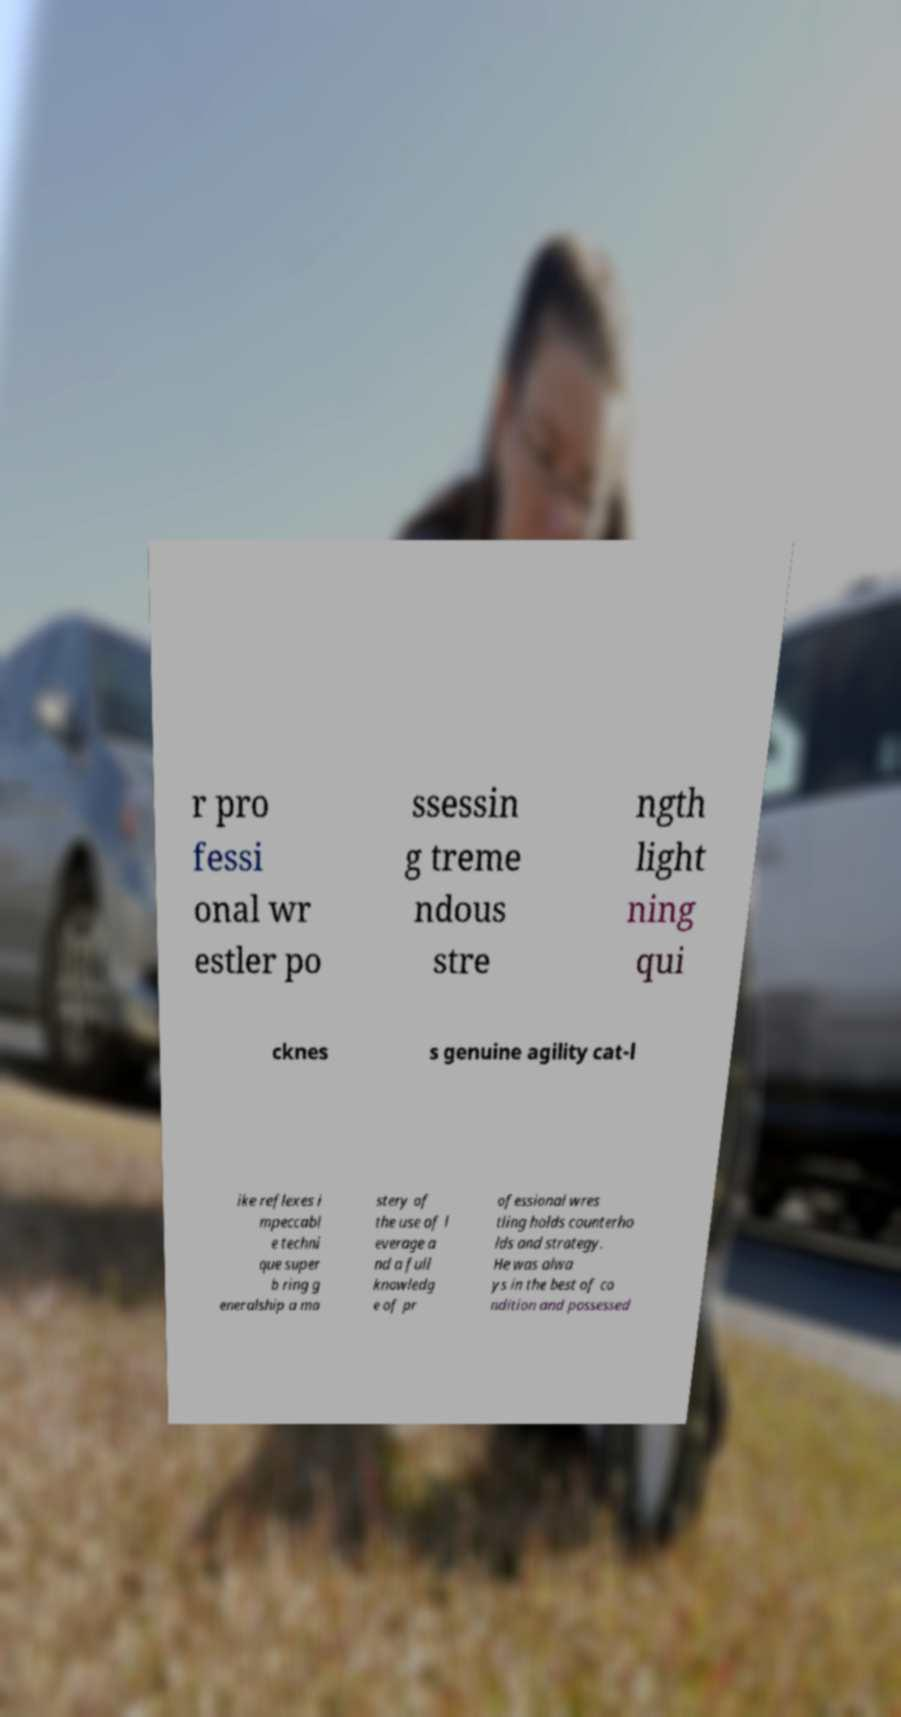Can you read and provide the text displayed in the image?This photo seems to have some interesting text. Can you extract and type it out for me? r pro fessi onal wr estler po ssessin g treme ndous stre ngth light ning qui cknes s genuine agility cat-l ike reflexes i mpeccabl e techni que super b ring g eneralship a ma stery of the use of l everage a nd a full knowledg e of pr ofessional wres tling holds counterho lds and strategy. He was alwa ys in the best of co ndition and possessed 